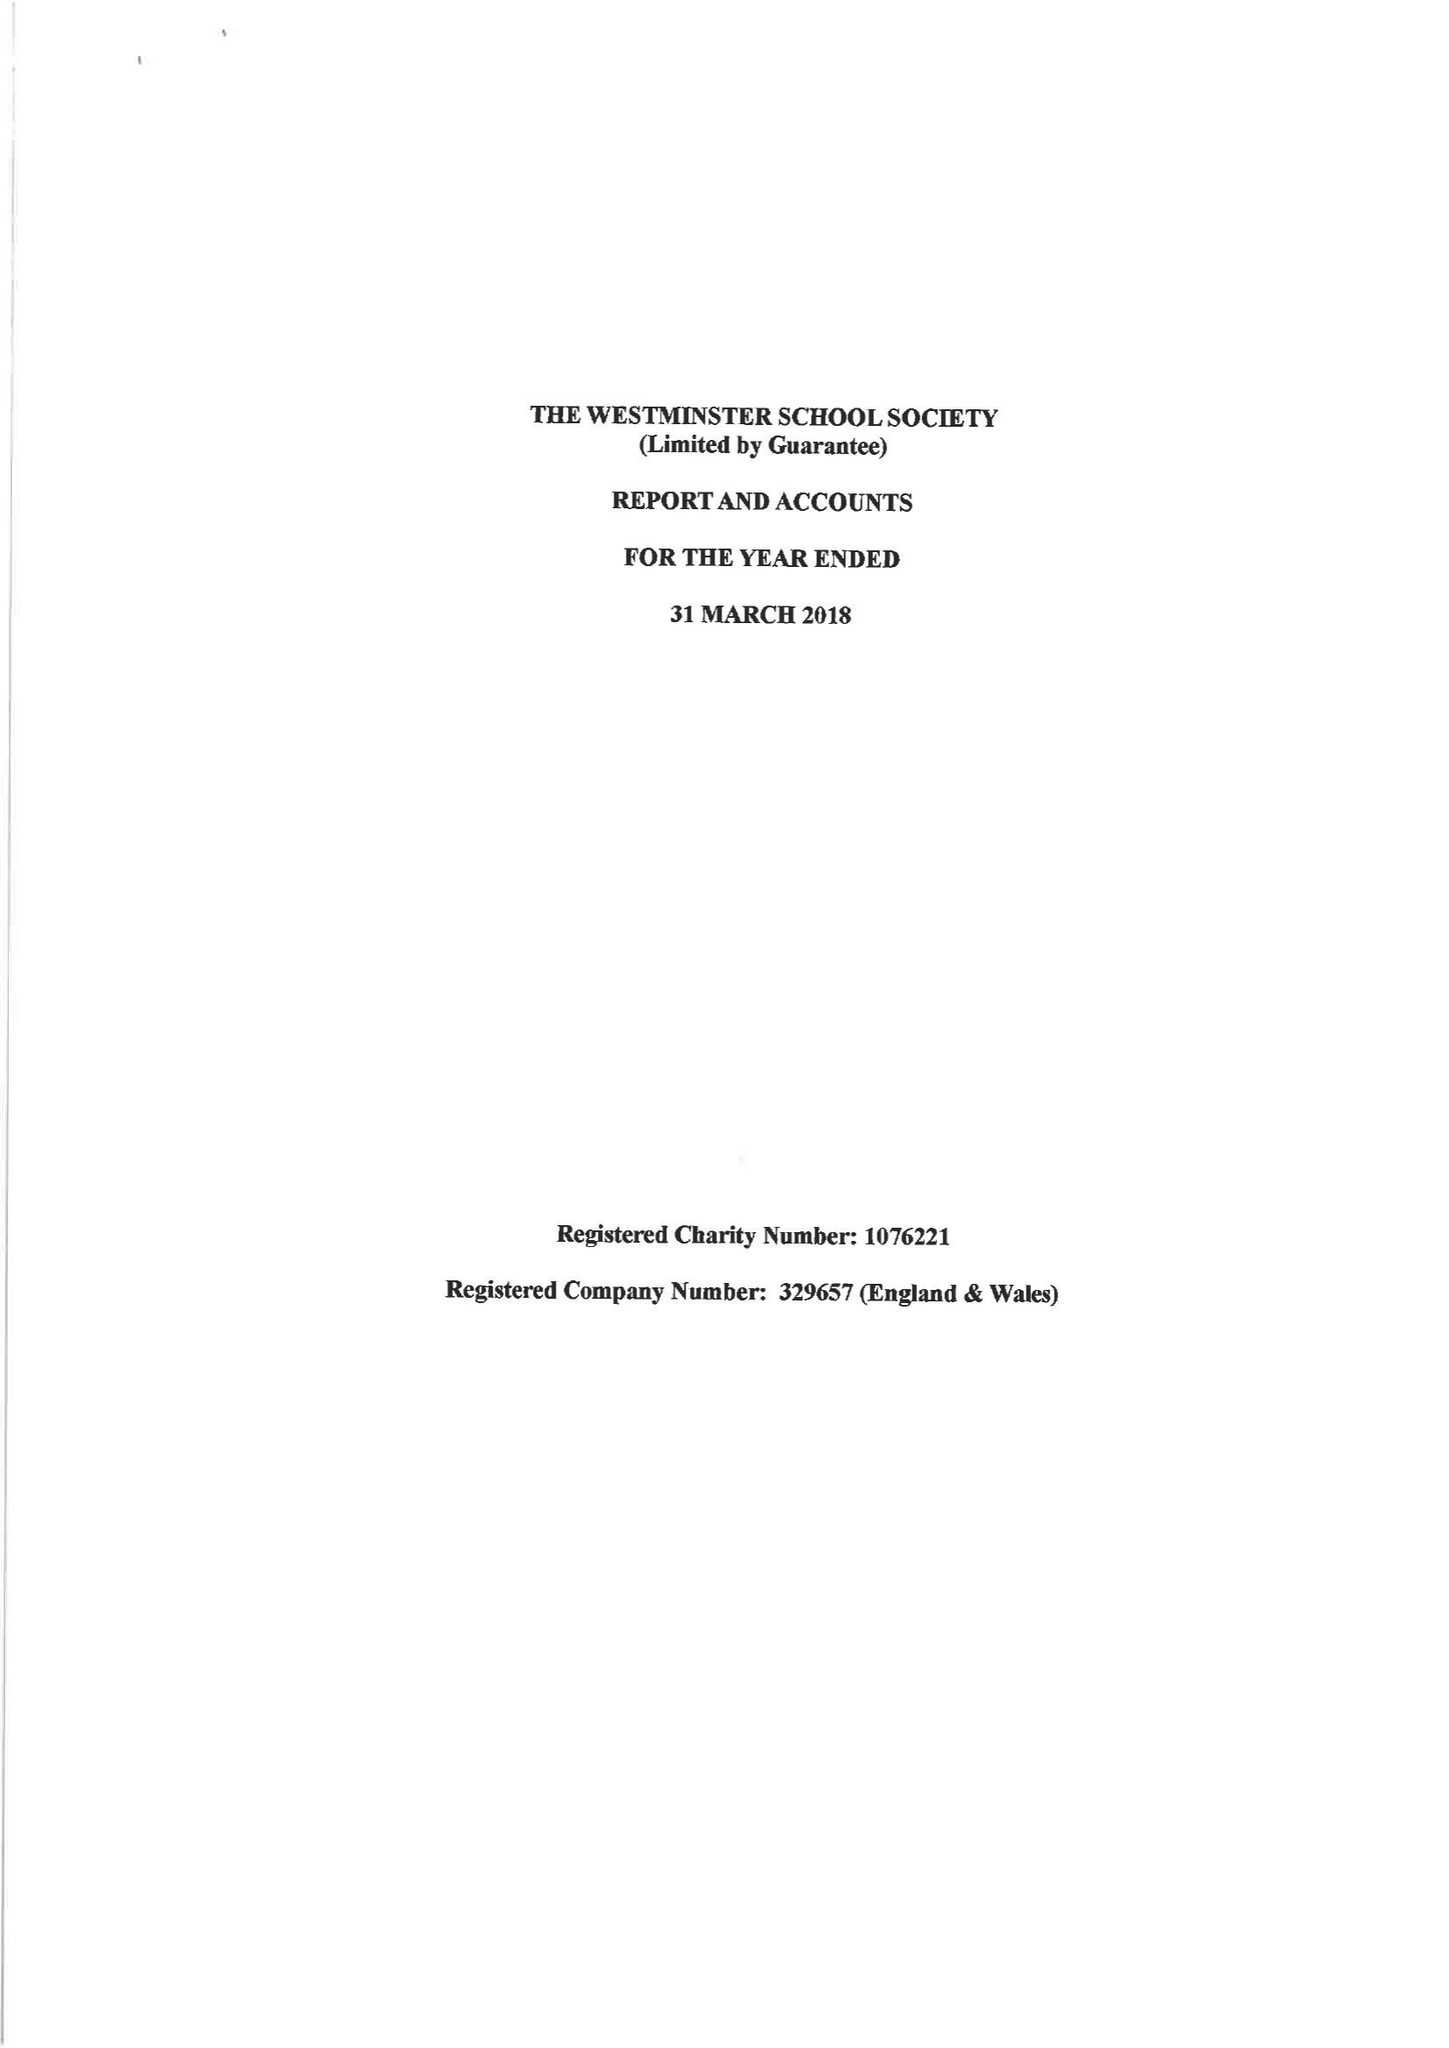What is the value for the address__post_town?
Answer the question using a single word or phrase. LONDON 